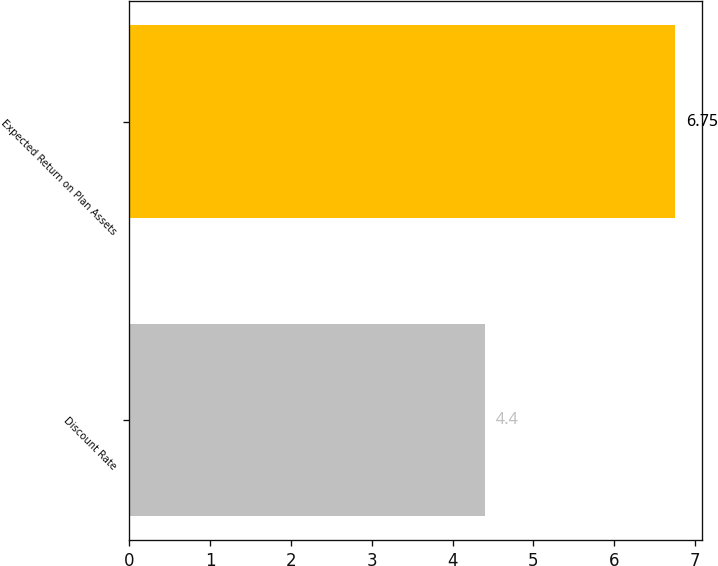Convert chart to OTSL. <chart><loc_0><loc_0><loc_500><loc_500><bar_chart><fcel>Discount Rate<fcel>Expected Return on Plan Assets<nl><fcel>4.4<fcel>6.75<nl></chart> 